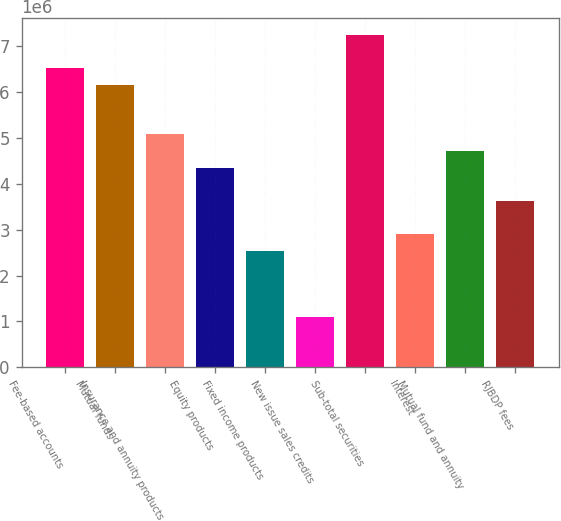<chart> <loc_0><loc_0><loc_500><loc_500><bar_chart><fcel>Fee-based accounts<fcel>Mutual funds<fcel>Insurance and annuity products<fcel>Equity products<fcel>Fixed income products<fcel>New issue sales credits<fcel>Sub-total securities<fcel>Interest<fcel>Mutual fund and annuity<fcel>RJBDP fees<nl><fcel>6.5199e+06<fcel>6.15825e+06<fcel>5.07331e+06<fcel>4.35001e+06<fcel>2.54177e+06<fcel>1.09518e+06<fcel>7.2432e+06<fcel>2.90342e+06<fcel>4.71166e+06<fcel>3.62672e+06<nl></chart> 